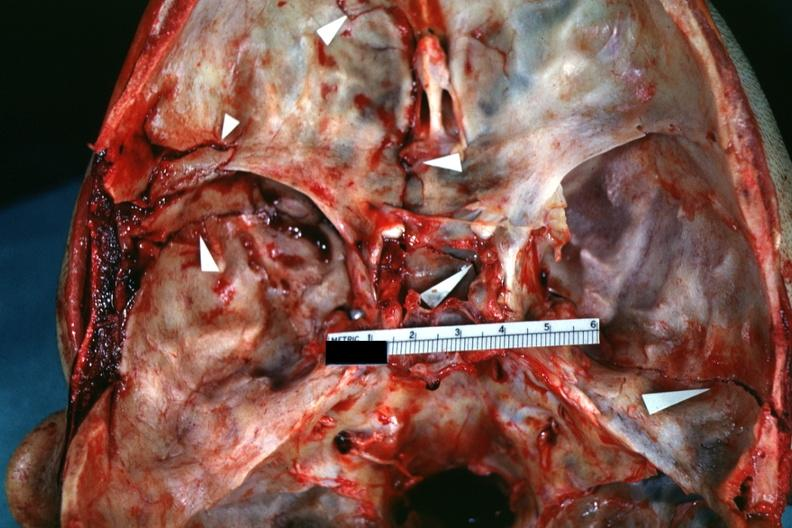what is present?
Answer the question using a single word or phrase. Bone, calvarium 